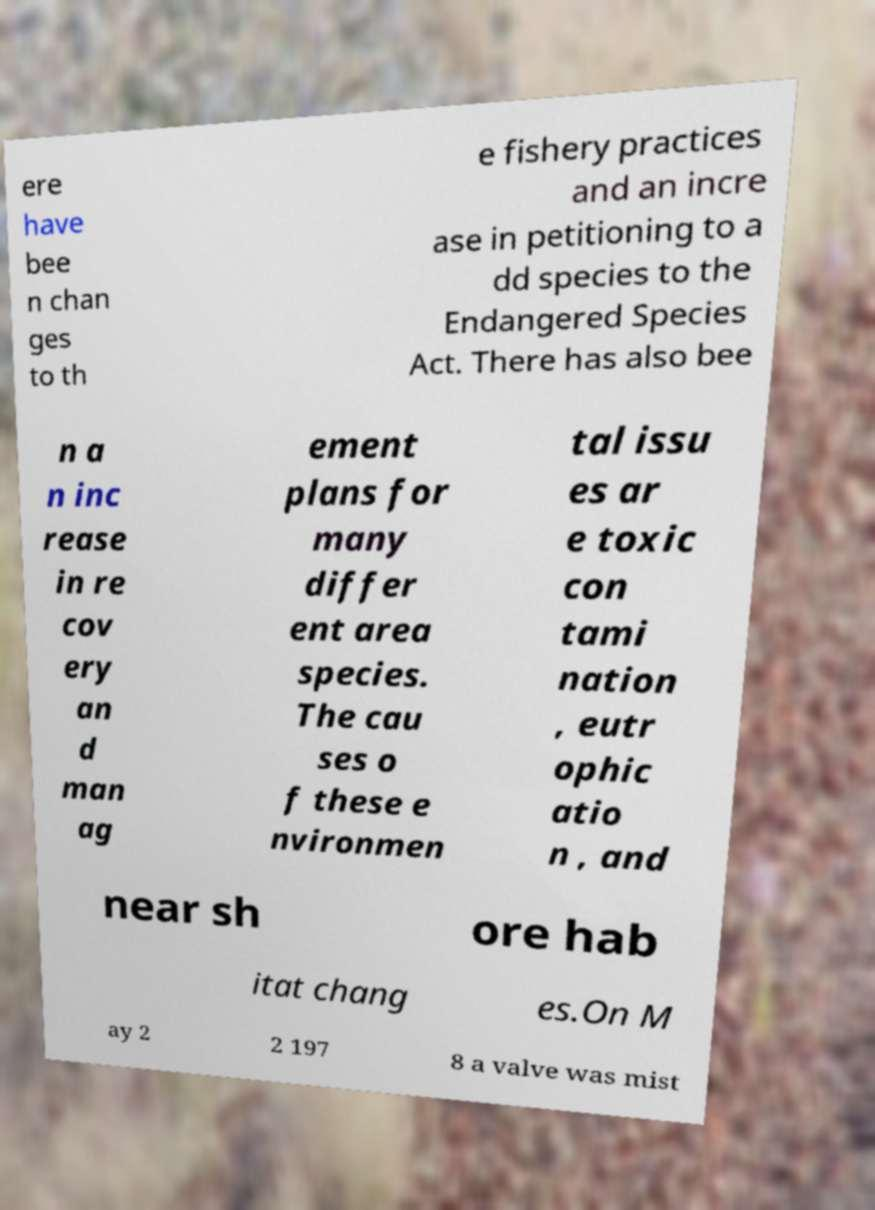I need the written content from this picture converted into text. Can you do that? ere have bee n chan ges to th e fishery practices and an incre ase in petitioning to a dd species to the Endangered Species Act. There has also bee n a n inc rease in re cov ery an d man ag ement plans for many differ ent area species. The cau ses o f these e nvironmen tal issu es ar e toxic con tami nation , eutr ophic atio n , and near sh ore hab itat chang es.On M ay 2 2 197 8 a valve was mist 